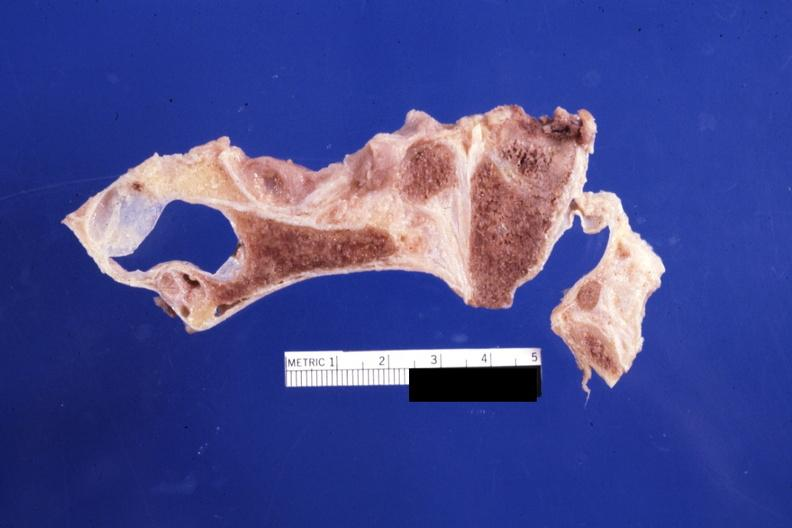what is present?
Answer the question using a single word or phrase. Bone 